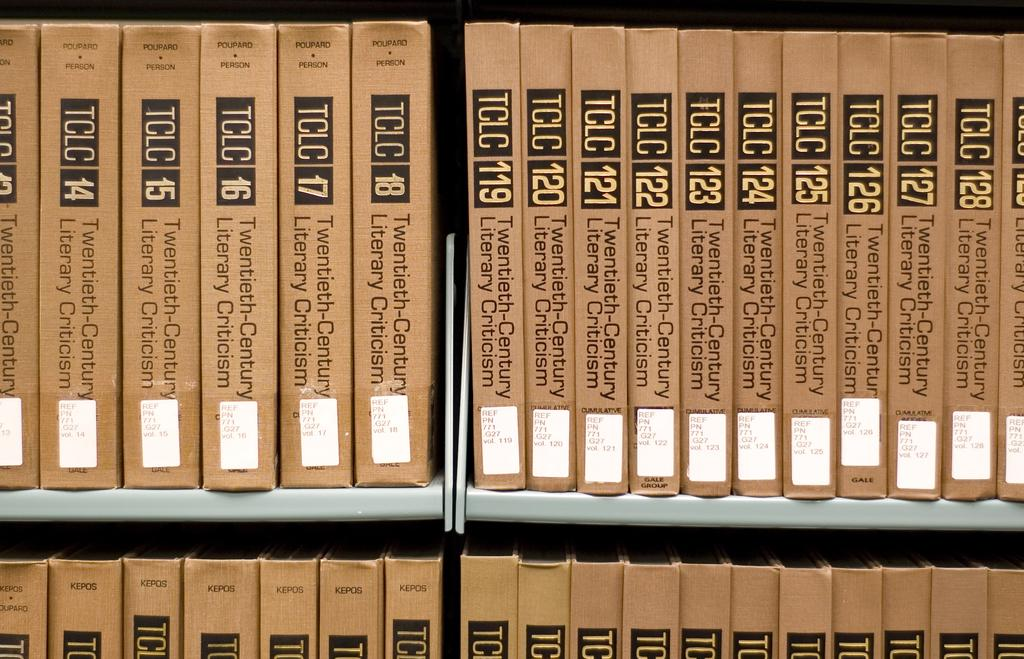Provide a one-sentence caption for the provided image. Rows of brown TCLC books including their numbers. 